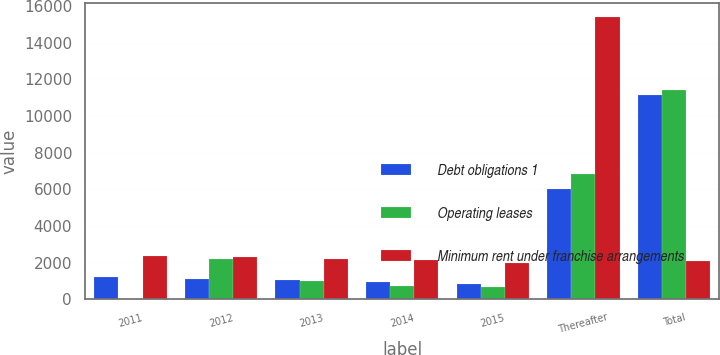Convert chart. <chart><loc_0><loc_0><loc_500><loc_500><stacked_bar_chart><ecel><fcel>2011<fcel>2012<fcel>2013<fcel>2014<fcel>2015<fcel>Thereafter<fcel>Total<nl><fcel>Debt obligations 1<fcel>1200<fcel>1116<fcel>1034<fcel>926<fcel>827<fcel>6018<fcel>11121<nl><fcel>Operating leases<fcel>8<fcel>2212<fcel>1007<fcel>708<fcel>675<fcel>6818<fcel>11428<nl><fcel>Minimum rent under franchise arrangements<fcel>2349<fcel>2289<fcel>2216<fcel>2120<fcel>2001<fcel>15379<fcel>2060.5<nl></chart> 